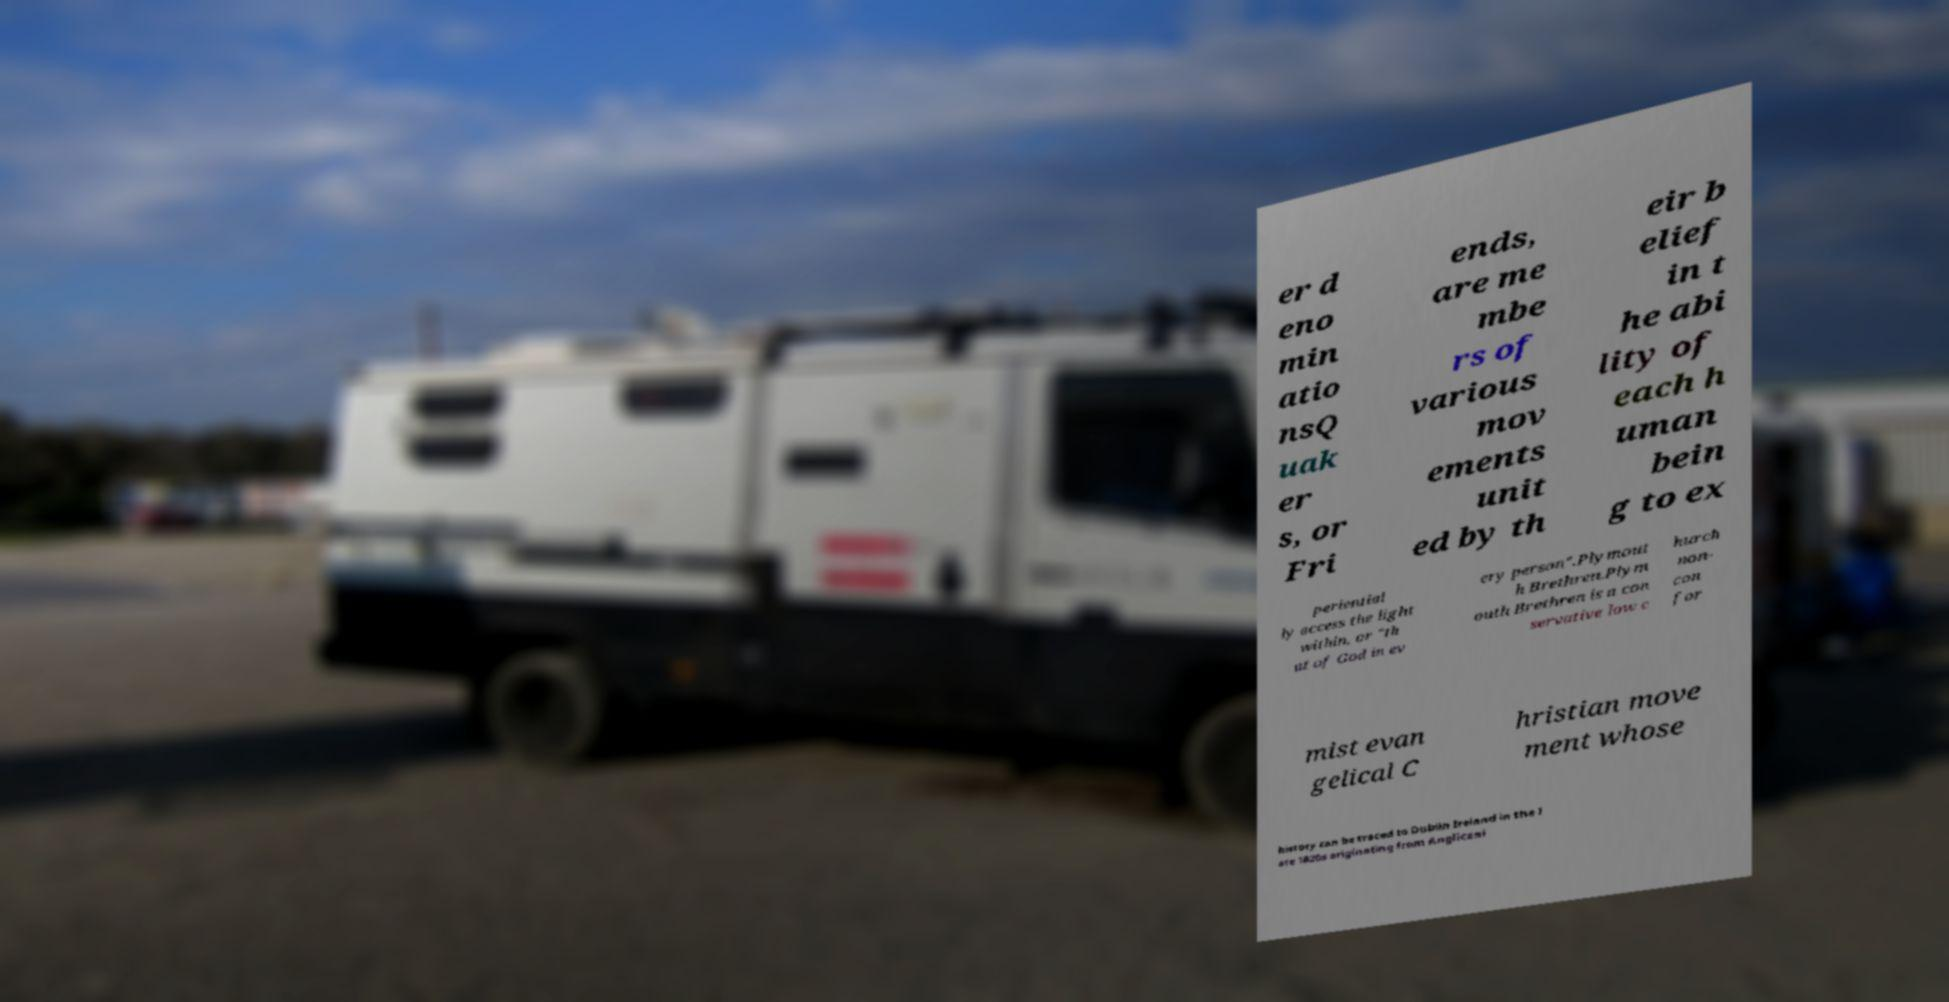I need the written content from this picture converted into text. Can you do that? er d eno min atio nsQ uak er s, or Fri ends, are me mbe rs of various mov ements unit ed by th eir b elief in t he abi lity of each h uman bein g to ex periential ly access the light within, or "th at of God in ev ery person".Plymout h Brethren.Plym outh Brethren is a con servative low c hurch non- con for mist evan gelical C hristian move ment whose history can be traced to Dublin Ireland in the l ate 1820s originating from Anglicani 